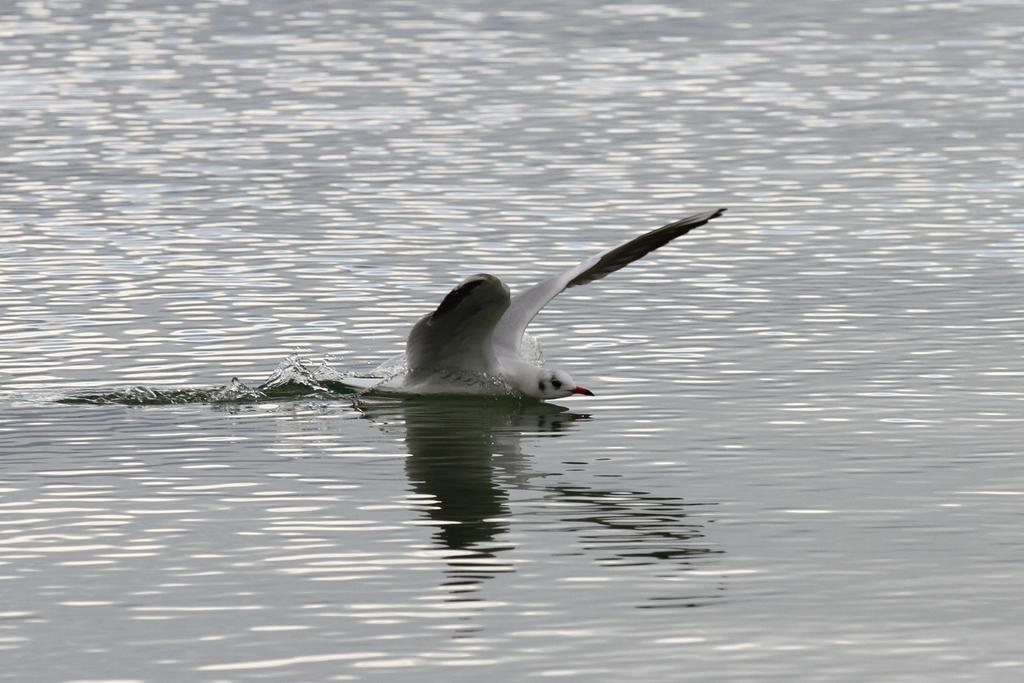Can you describe this image briefly? In this image we can see a bird in the water. 